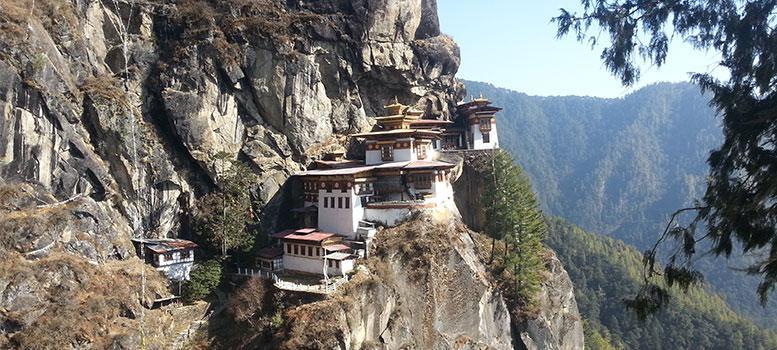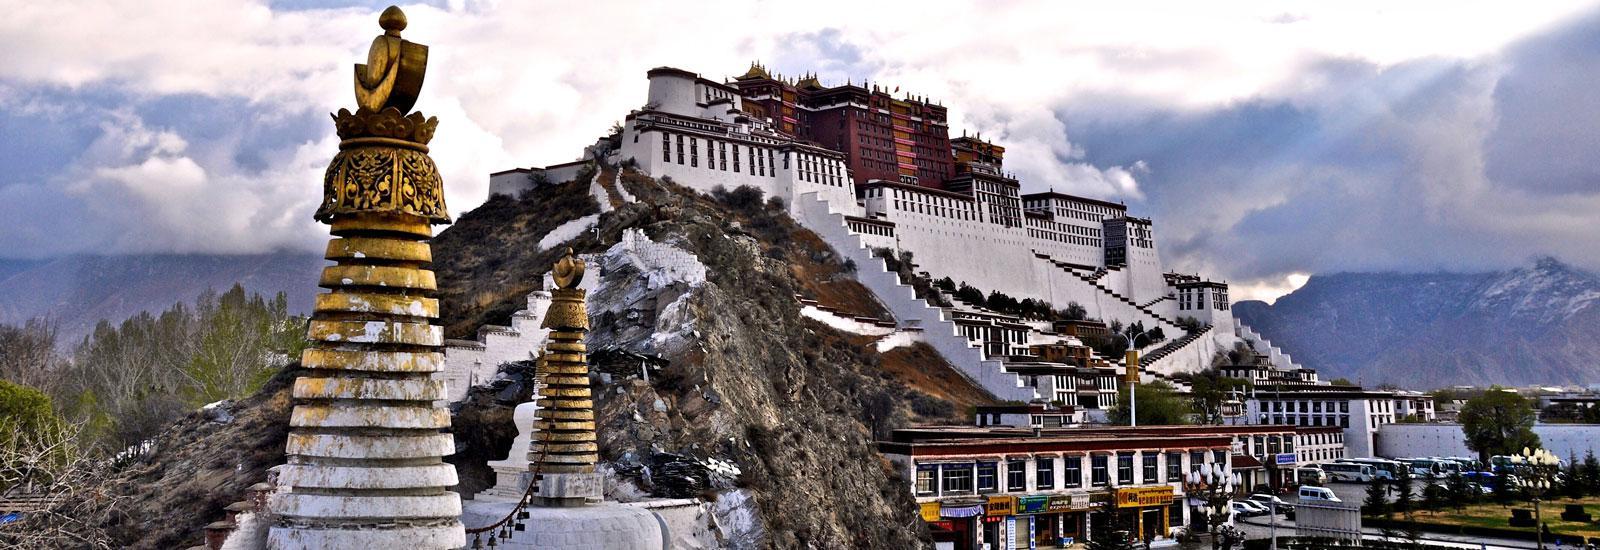The first image is the image on the left, the second image is the image on the right. For the images shown, is this caption "In at least one image there are at least three homes dug in to the rocks facing forward and right." true? Answer yes or no. Yes. 